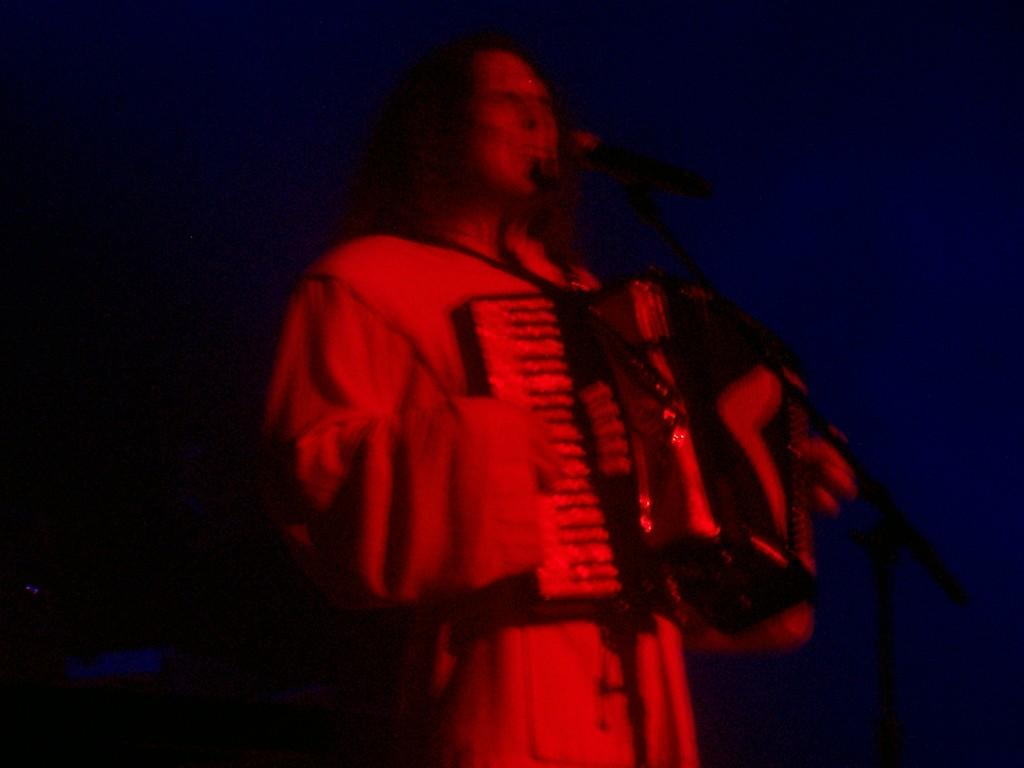What is the main subject of the image? The main subject of the image is a person playing a musical instrument. What object is in front of the person? There is a microphone in front of the person. How would you describe the background of the image? The background of the image is dark. How many teeth can be seen on the dolls in the image? There are no dolls present in the image, so it is not possible to determine the number of teeth on any dolls. 